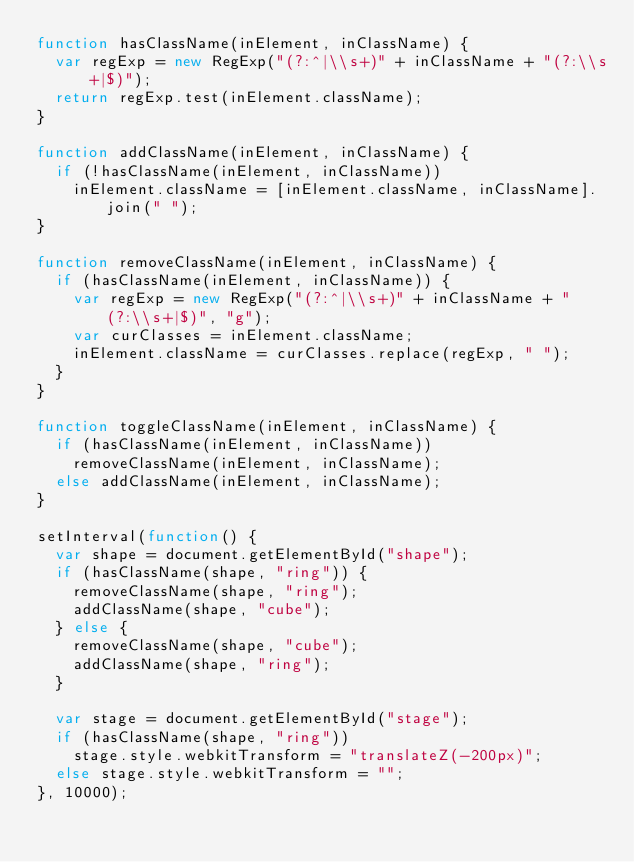<code> <loc_0><loc_0><loc_500><loc_500><_JavaScript_>function hasClassName(inElement, inClassName) {
  var regExp = new RegExp("(?:^|\\s+)" + inClassName + "(?:\\s+|$)");
  return regExp.test(inElement.className);
}

function addClassName(inElement, inClassName) {
  if (!hasClassName(inElement, inClassName))
    inElement.className = [inElement.className, inClassName].join(" ");
}

function removeClassName(inElement, inClassName) {
  if (hasClassName(inElement, inClassName)) {
    var regExp = new RegExp("(?:^|\\s+)" + inClassName + "(?:\\s+|$)", "g");
    var curClasses = inElement.className;
    inElement.className = curClasses.replace(regExp, " ");
  }
}

function toggleClassName(inElement, inClassName) {
  if (hasClassName(inElement, inClassName))
    removeClassName(inElement, inClassName);
  else addClassName(inElement, inClassName);
}

setInterval(function() {
  var shape = document.getElementById("shape");
  if (hasClassName(shape, "ring")) {
    removeClassName(shape, "ring");
    addClassName(shape, "cube");
  } else {
    removeClassName(shape, "cube");
    addClassName(shape, "ring");
  }

  var stage = document.getElementById("stage");
  if (hasClassName(shape, "ring"))
    stage.style.webkitTransform = "translateZ(-200px)";
  else stage.style.webkitTransform = "";
}, 10000);
</code> 